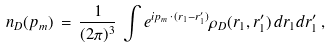Convert formula to latex. <formula><loc_0><loc_0><loc_500><loc_500>n _ { D } ( { p } _ { m } ) \, = \, \frac { 1 } { ( 2 \pi ) ^ { 3 } } \, \int e ^ { i { p } _ { m } \, \cdot \, ( { r } _ { 1 } - { r } _ { 1 } ^ { \prime } ) } \rho _ { D } ( { r } _ { 1 } , { r } _ { 1 } ^ { \prime } ) \, d { r } _ { 1 } d { r } _ { 1 } ^ { \prime } \, ,</formula> 